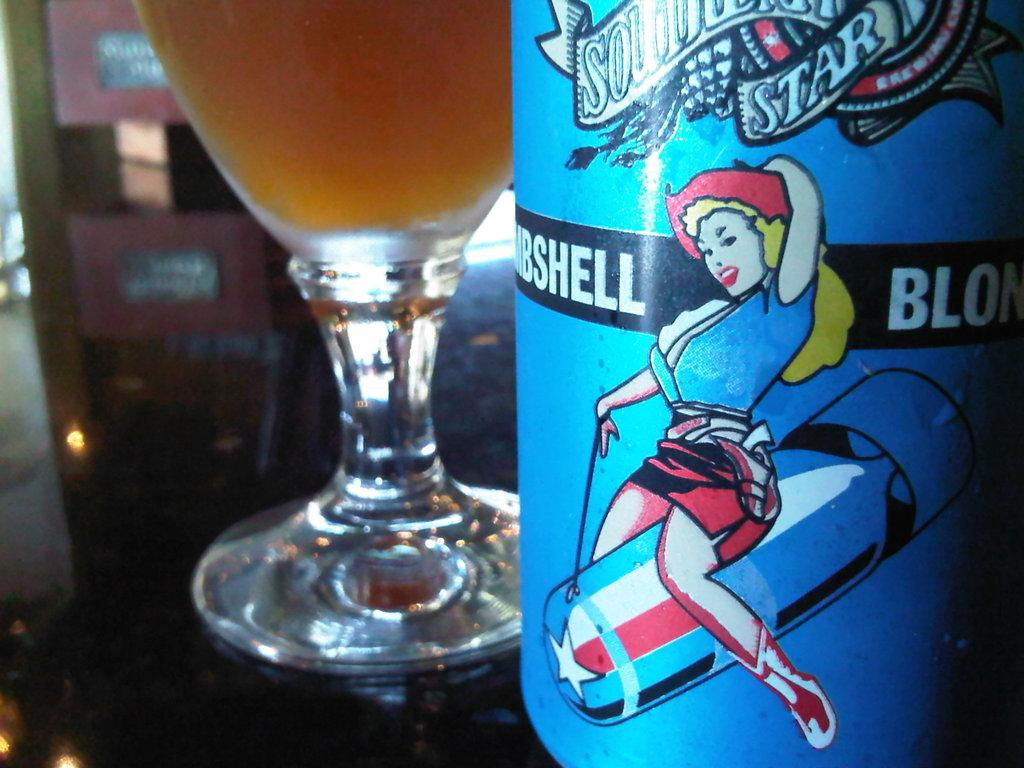<image>
Present a compact description of the photo's key features. a partly seen bottle of Bombshell Blonde liquor and a glass filled with it. 